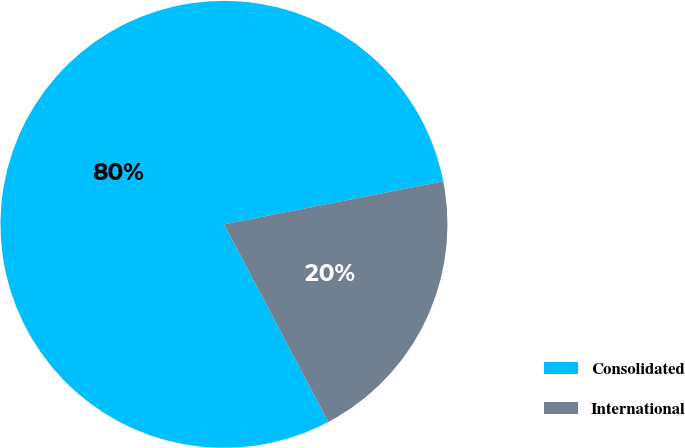Convert chart. <chart><loc_0><loc_0><loc_500><loc_500><pie_chart><fcel>Consolidated<fcel>International<nl><fcel>79.65%<fcel>20.35%<nl></chart> 